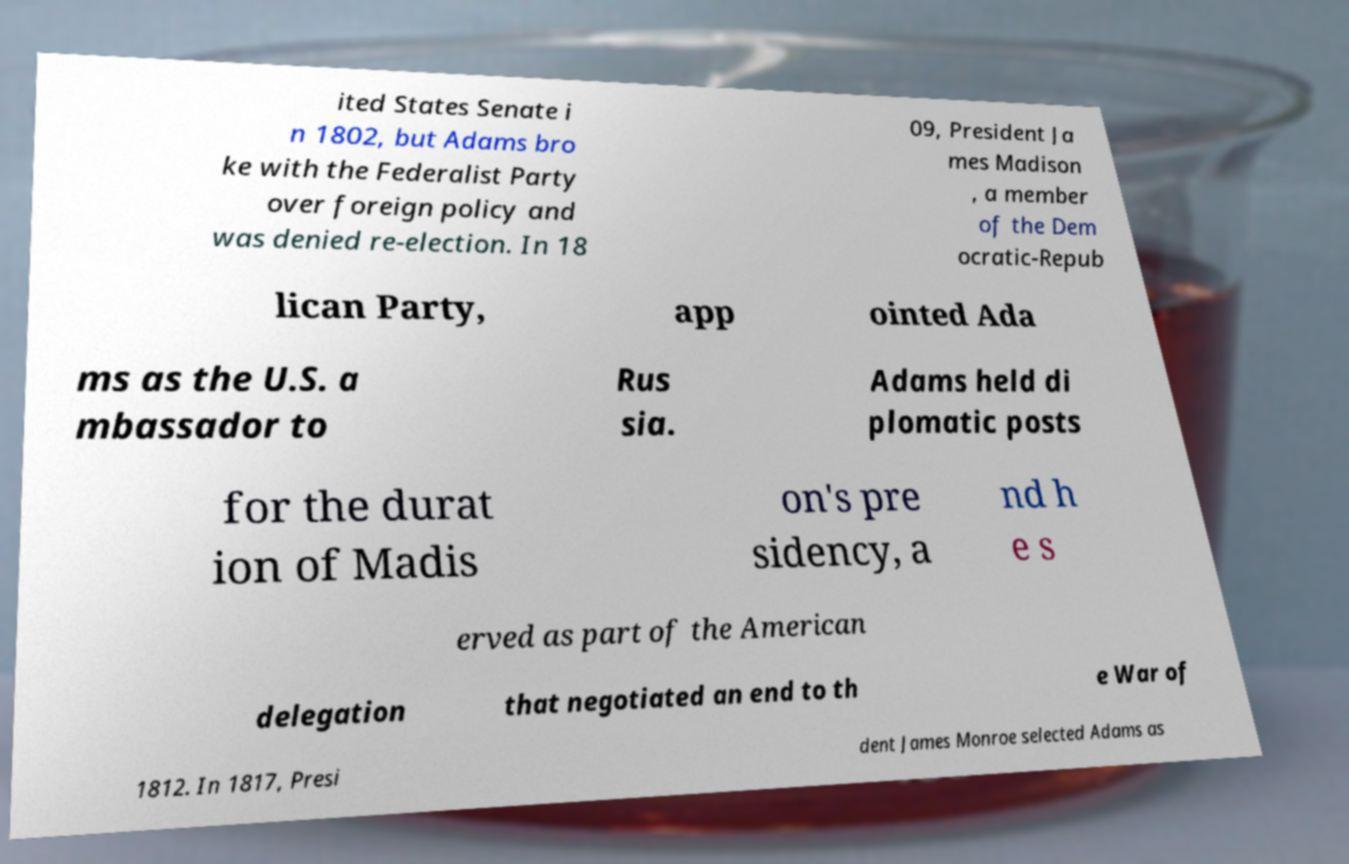Please identify and transcribe the text found in this image. ited States Senate i n 1802, but Adams bro ke with the Federalist Party over foreign policy and was denied re-election. In 18 09, President Ja mes Madison , a member of the Dem ocratic-Repub lican Party, app ointed Ada ms as the U.S. a mbassador to Rus sia. Adams held di plomatic posts for the durat ion of Madis on's pre sidency, a nd h e s erved as part of the American delegation that negotiated an end to th e War of 1812. In 1817, Presi dent James Monroe selected Adams as 